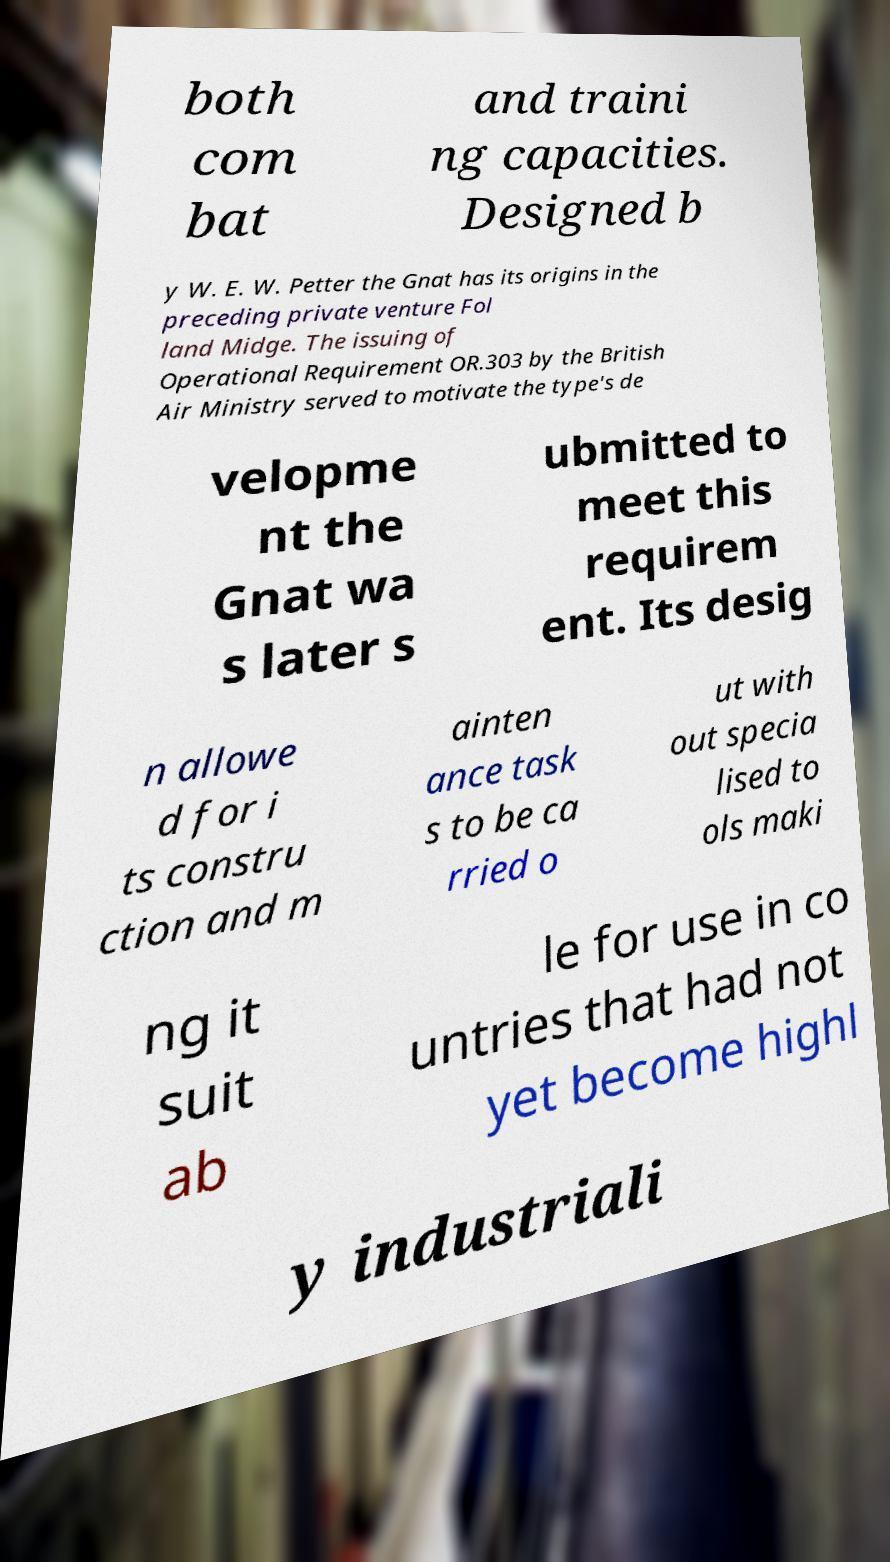For documentation purposes, I need the text within this image transcribed. Could you provide that? both com bat and traini ng capacities. Designed b y W. E. W. Petter the Gnat has its origins in the preceding private venture Fol land Midge. The issuing of Operational Requirement OR.303 by the British Air Ministry served to motivate the type's de velopme nt the Gnat wa s later s ubmitted to meet this requirem ent. Its desig n allowe d for i ts constru ction and m ainten ance task s to be ca rried o ut with out specia lised to ols maki ng it suit ab le for use in co untries that had not yet become highl y industriali 